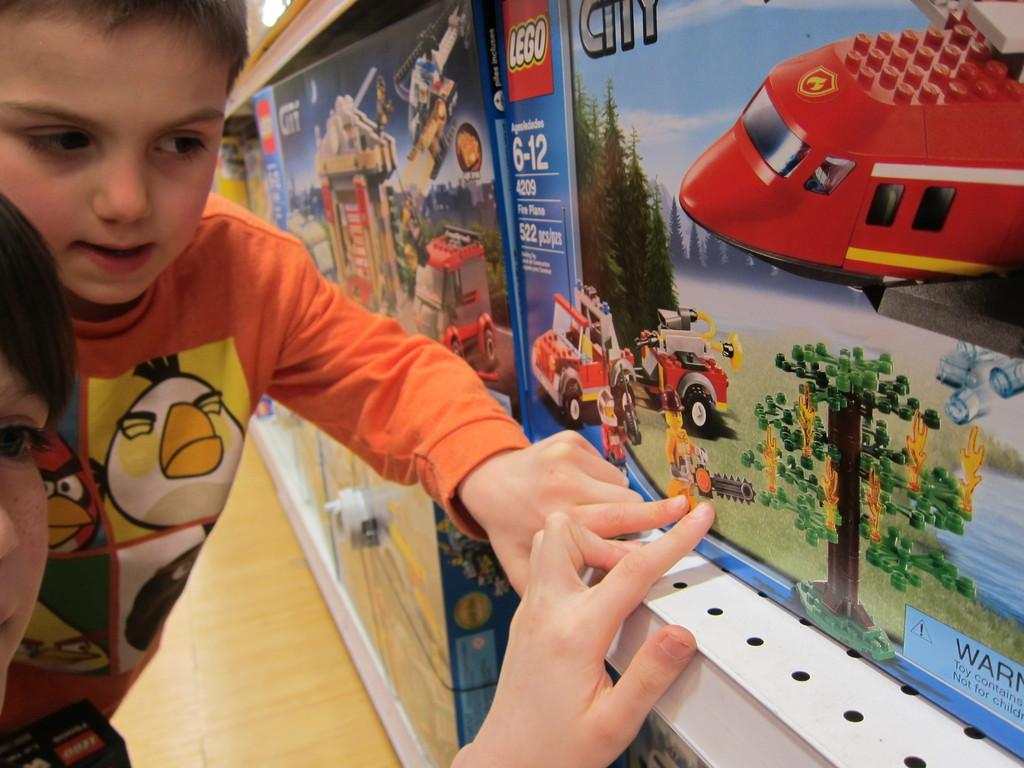Provide a one-sentence caption for the provided image. Two boys pointing to a box on a shelf of Lego City. 